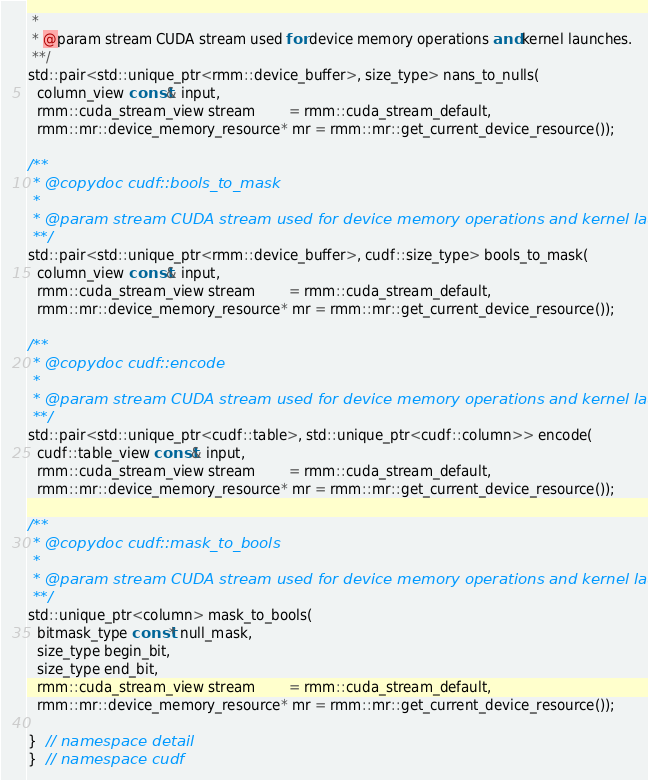Convert code to text. <code><loc_0><loc_0><loc_500><loc_500><_C++_> *
 * @param stream CUDA stream used for device memory operations and kernel launches.
 **/
std::pair<std::unique_ptr<rmm::device_buffer>, size_type> nans_to_nulls(
  column_view const& input,
  rmm::cuda_stream_view stream        = rmm::cuda_stream_default,
  rmm::mr::device_memory_resource* mr = rmm::mr::get_current_device_resource());

/**
 * @copydoc cudf::bools_to_mask
 *
 * @param stream CUDA stream used for device memory operations and kernel launches.
 **/
std::pair<std::unique_ptr<rmm::device_buffer>, cudf::size_type> bools_to_mask(
  column_view const& input,
  rmm::cuda_stream_view stream        = rmm::cuda_stream_default,
  rmm::mr::device_memory_resource* mr = rmm::mr::get_current_device_resource());

/**
 * @copydoc cudf::encode
 *
 * @param stream CUDA stream used for device memory operations and kernel launches.
 **/
std::pair<std::unique_ptr<cudf::table>, std::unique_ptr<cudf::column>> encode(
  cudf::table_view const& input,
  rmm::cuda_stream_view stream        = rmm::cuda_stream_default,
  rmm::mr::device_memory_resource* mr = rmm::mr::get_current_device_resource());

/**
 * @copydoc cudf::mask_to_bools
 *
 * @param stream CUDA stream used for device memory operations and kernel launches.
 **/
std::unique_ptr<column> mask_to_bools(
  bitmask_type const* null_mask,
  size_type begin_bit,
  size_type end_bit,
  rmm::cuda_stream_view stream        = rmm::cuda_stream_default,
  rmm::mr::device_memory_resource* mr = rmm::mr::get_current_device_resource());

}  // namespace detail
}  // namespace cudf
</code> 